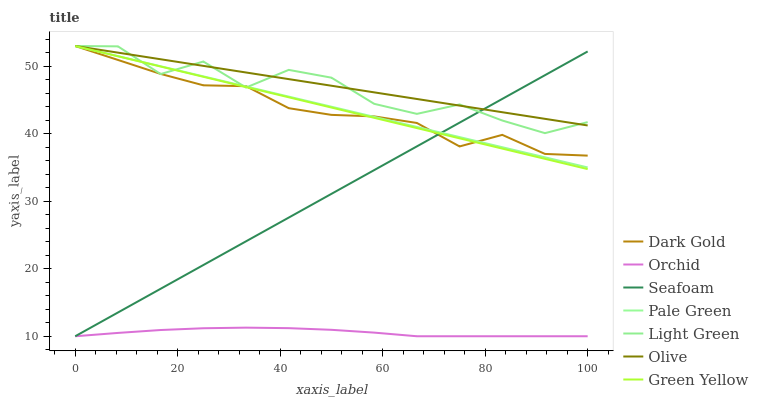Does Orchid have the minimum area under the curve?
Answer yes or no. Yes. Does Olive have the maximum area under the curve?
Answer yes or no. Yes. Does Seafoam have the minimum area under the curve?
Answer yes or no. No. Does Seafoam have the maximum area under the curve?
Answer yes or no. No. Is Olive the smoothest?
Answer yes or no. Yes. Is Light Green the roughest?
Answer yes or no. Yes. Is Seafoam the smoothest?
Answer yes or no. No. Is Seafoam the roughest?
Answer yes or no. No. Does Pale Green have the lowest value?
Answer yes or no. No. Does Seafoam have the highest value?
Answer yes or no. No. Is Orchid less than Dark Gold?
Answer yes or no. Yes. Is Olive greater than Orchid?
Answer yes or no. Yes. Does Orchid intersect Dark Gold?
Answer yes or no. No. 